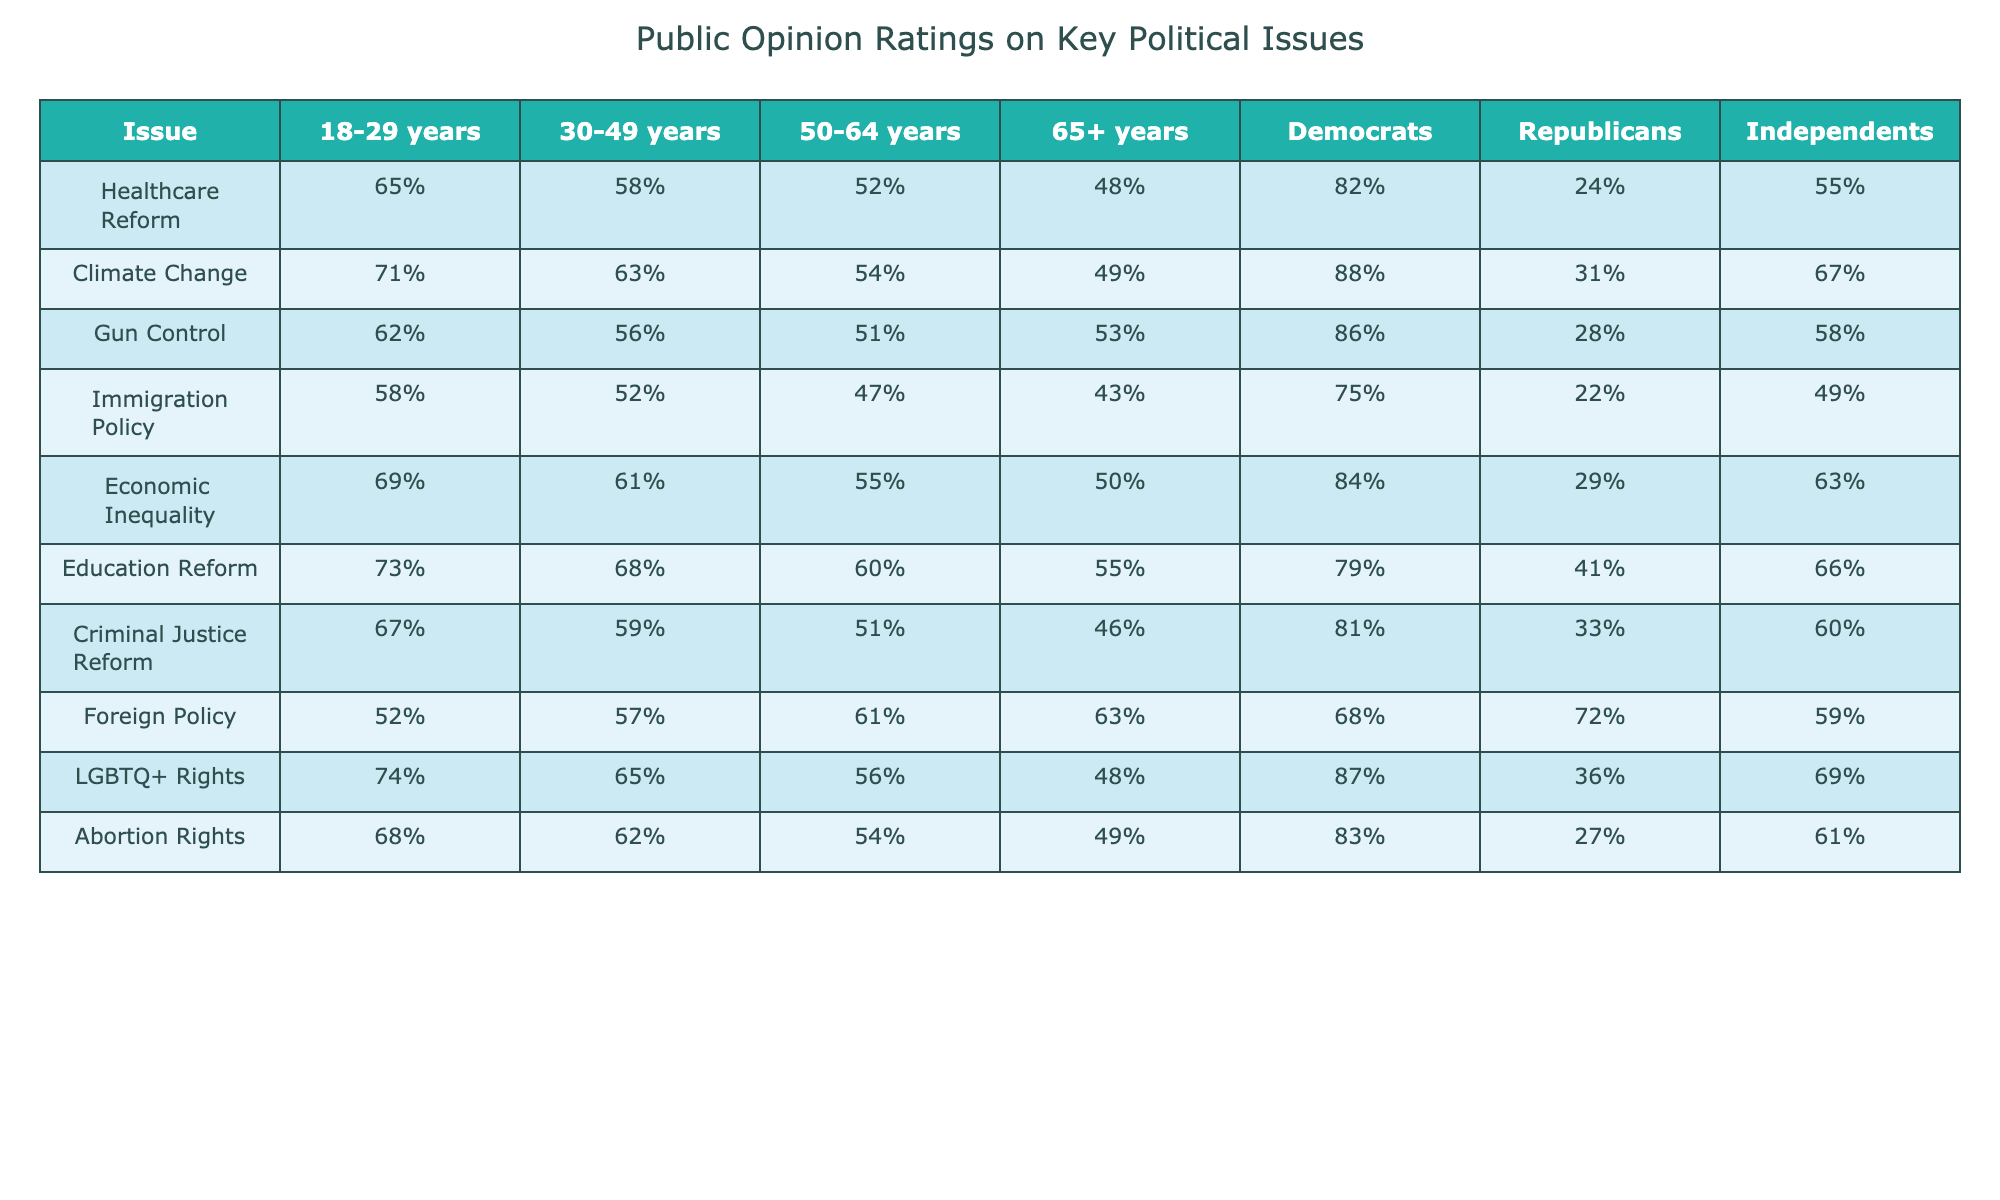What percentage of 18-29 year-olds support Healthcare Reform? The table indicates that 65% of the 18-29 years demographic supports Healthcare Reform. We can find this value directly in the corresponding cell of the table.
Answer: 65% Which age group has the highest support for Climate Change? The 18-29 years age group has the highest support for Climate Change at 71%. This is verified by comparing the percentages across all age groups in the table.
Answer: 18-29 years What is the percentage difference in support for Gun Control between 30-49 years and 50-64 years? To find the percentage difference, subtract the support of 50-64 years (51%) from 30-49 years (56%), resulting in 56% - 51% = 5%.
Answer: 5% Do more Democrats or Independents support Immigration Policy? Democrats show 75% support for Immigration Policy while Independents have 49%. Comparing these two values shows that Democrats have higher support.
Answer: Democrats What is the average support for Economic Inequality across all age groups? The average is calculated by summing the percentages of all age groups (69% + 61% + 55% + 50%) = 235, then dividing by the number of age groups (4), leading to 235/4 = 58.75%.
Answer: 58.75% Which political issue has the highest support from Republicans? The highest support from Republicans is seen in Foreign Policy with a value of 72%. This can be determined by referencing the Republican column and identifying the maximum value.
Answer: Foreign Policy What is the percentage support for LGBTQ+ Rights among the 65+ age group? The table shows that the support for LGBTQ+ Rights among the 65+ years group is 48%. This value is directly extracted from the specified cell in the table.
Answer: 48% Is there a significant difference in support for Abortion Rights between the age groups of 50-64 years and 65+ years? The difference is determined by subtracting the support of 65+ years (49%) from 50-64 years (54%), which gives us 54% - 49% = 5%. This indicates a noticeable difference in support.
Answer: Yes How do Independents' views on Healthcare Reform compare to those of Republicans? Independents support Healthcare Reform at 55% whereas Republicans only support it at 24%. This shows that Independents have a significantly higher percentage of support compared to Republicans.
Answer: Independents have higher support What percentage of the 30-49 year age group supports both Climate Change and Gun Control? The Climate Change support is 63% and Gun Control support is 56%. To find both, we note that support for both issues can simply be expressed as two separate values since no overlap is requested. Thus, both percentages are noted as they stand.
Answer: 63% for Climate Change, 56% for Gun Control 